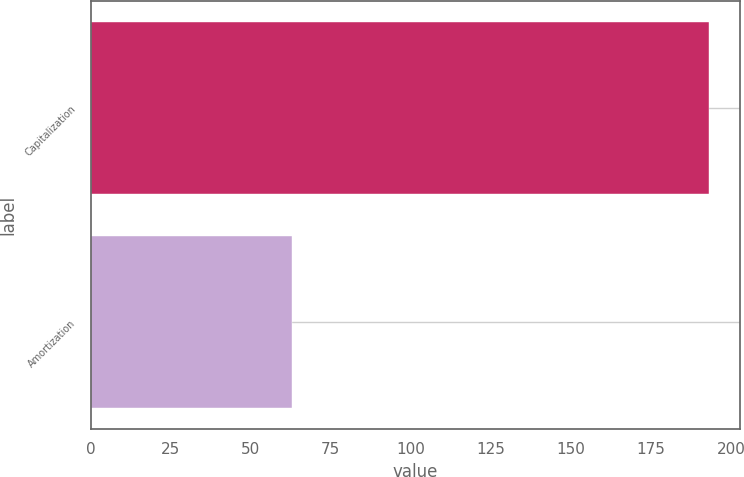Convert chart. <chart><loc_0><loc_0><loc_500><loc_500><bar_chart><fcel>Capitalization<fcel>Amortization<nl><fcel>193<fcel>63<nl></chart> 